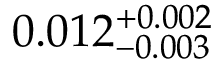<formula> <loc_0><loc_0><loc_500><loc_500>0 . 0 1 2 _ { - 0 . 0 0 3 } ^ { + 0 . 0 0 2 }</formula> 